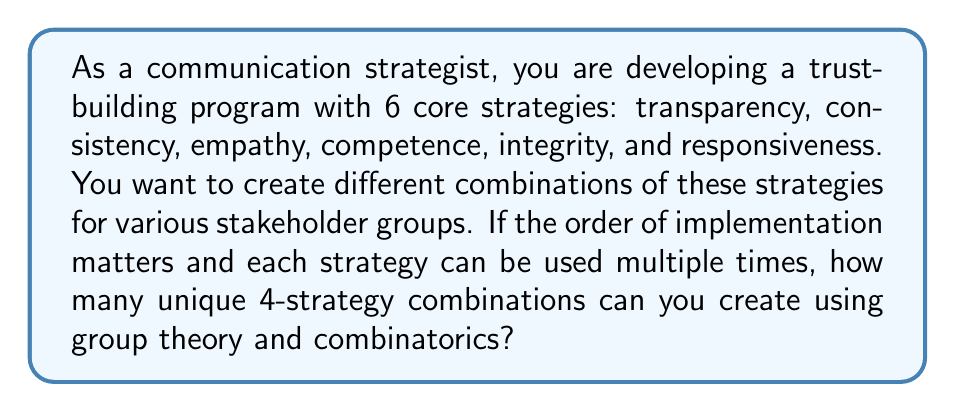Solve this math problem. To solve this problem, we can use the concept of permutations with repetition from combinatorics, which is related to group theory through the symmetric group.

Let's approach this step-by-step:

1) We have 6 core strategies to choose from, and we're creating combinations of 4 strategies.

2) The order matters (e.g., implementing transparency first and then consistency is different from implementing consistency first and then transparency).

3) We can use each strategy multiple times (e.g., we could have a combination of transparency, transparency, transparency, transparency).

4) This scenario is equivalent to the number of ways to arrange 4 elements, where each element can be any of the 6 strategies.

5) In group theory, this is related to the symmetric group $S_6$ acting on the set of 4-tuples with elements from the set of 6 strategies.

6) The formula for permutations with repetition is:

   $$n^r$$

   Where $n$ is the number of options for each position, and $r$ is the number of positions.

7) In this case, $n = 6$ (the number of strategies) and $r = 4$ (the length of each combination).

8) Therefore, the number of unique combinations is:

   $$6^4 = 6 \times 6 \times 6 \times 6 = 1296$$

This result represents the number of elements in the group of all possible 4-strategy combinations, considering the given conditions.
Answer: $1296$ unique 4-strategy combinations 